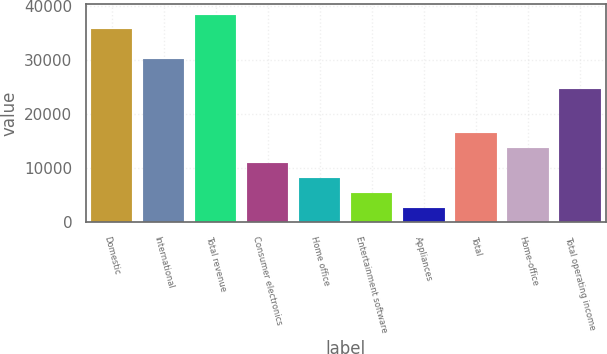Convert chart to OTSL. <chart><loc_0><loc_0><loc_500><loc_500><bar_chart><fcel>Domestic<fcel>International<fcel>Total revenue<fcel>Consumer electronics<fcel>Home office<fcel>Entertainment software<fcel>Appliances<fcel>Total<fcel>Home-office<fcel>Total operating income<nl><fcel>35662.6<fcel>30176.2<fcel>38405.8<fcel>10973.8<fcel>8230.6<fcel>5487.4<fcel>2744.2<fcel>16460.2<fcel>13717<fcel>24689.8<nl></chart> 